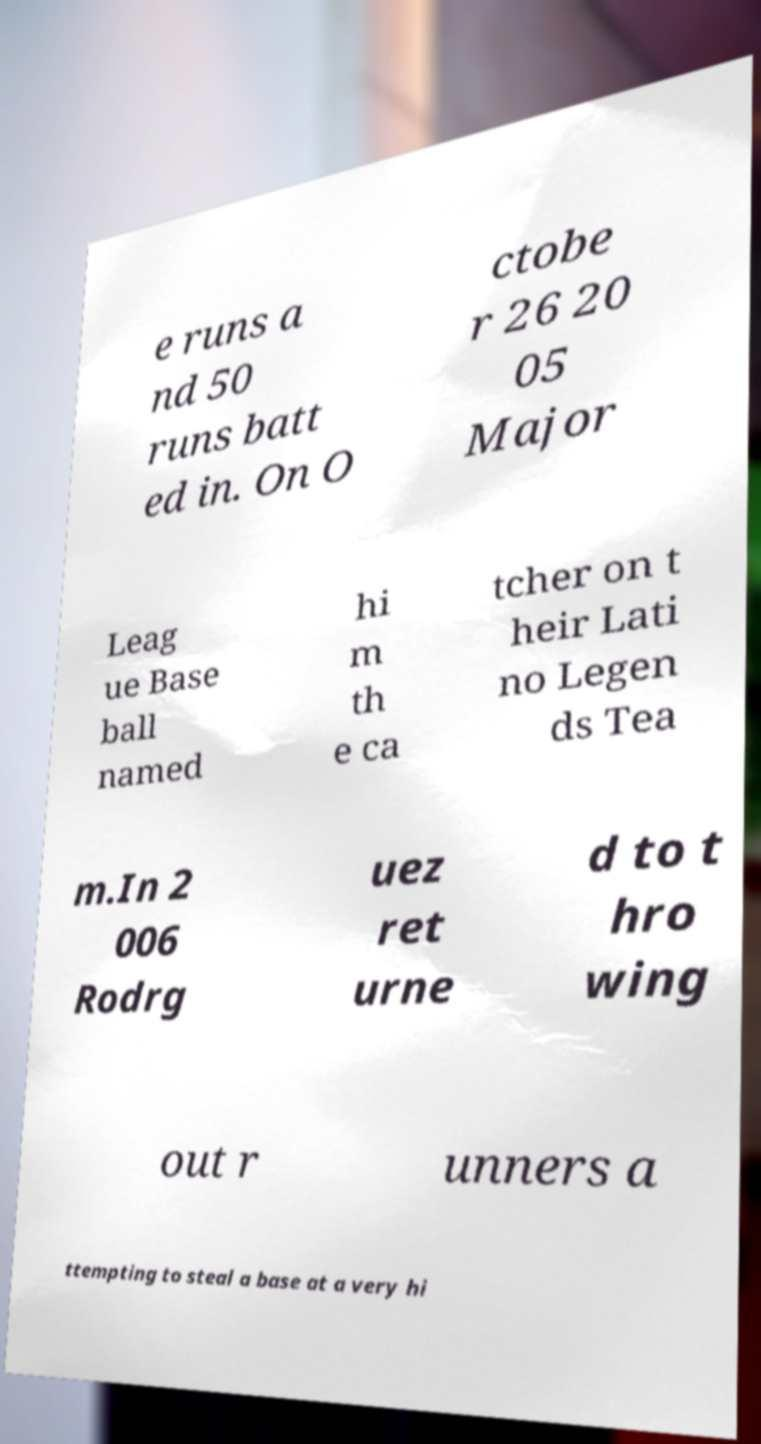Could you extract and type out the text from this image? e runs a nd 50 runs batt ed in. On O ctobe r 26 20 05 Major Leag ue Base ball named hi m th e ca tcher on t heir Lati no Legen ds Tea m.In 2 006 Rodrg uez ret urne d to t hro wing out r unners a ttempting to steal a base at a very hi 